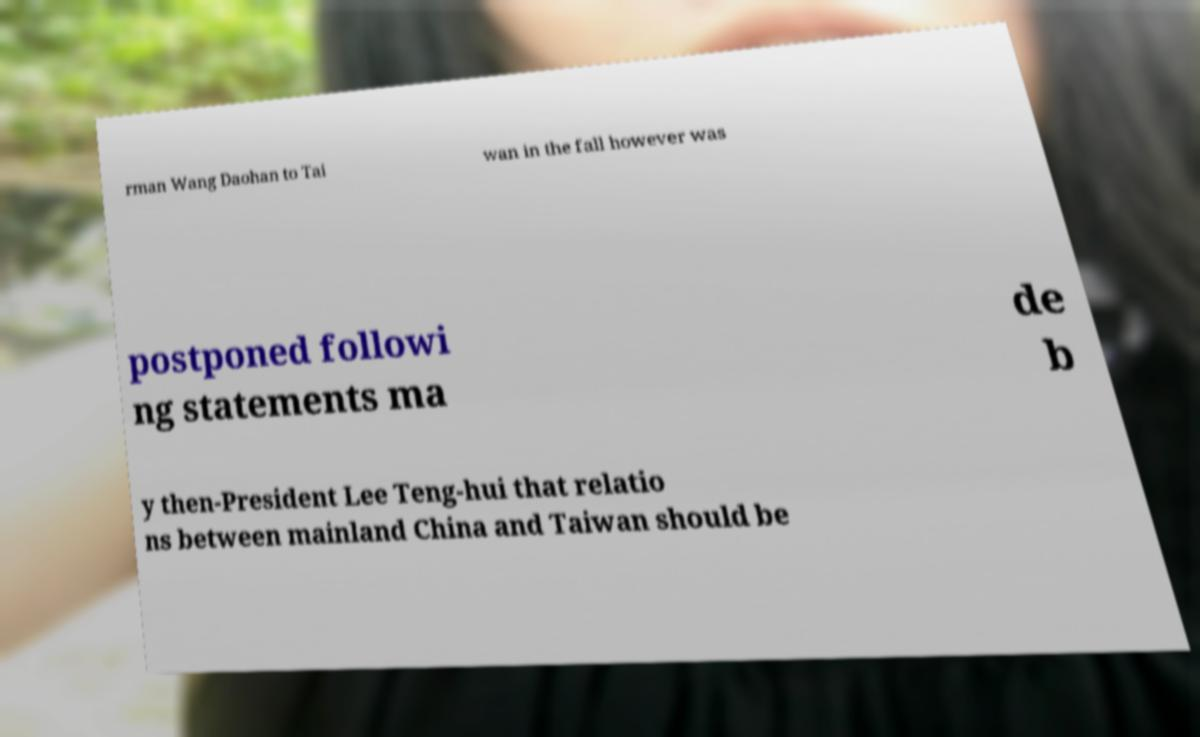Please identify and transcribe the text found in this image. rman Wang Daohan to Tai wan in the fall however was postponed followi ng statements ma de b y then-President Lee Teng-hui that relatio ns between mainland China and Taiwan should be 